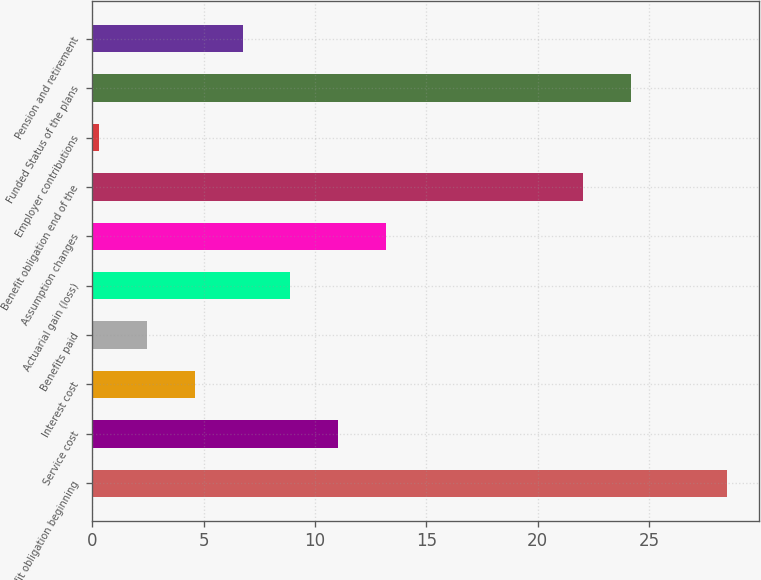Convert chart to OTSL. <chart><loc_0><loc_0><loc_500><loc_500><bar_chart><fcel>Benefit obligation beginning<fcel>Service cost<fcel>Interest cost<fcel>Benefits paid<fcel>Actuarial gain (loss)<fcel>Assumption changes<fcel>Benefit obligation end of the<fcel>Employer contributions<fcel>Funded Status of the plans<fcel>Pension and retirement<nl><fcel>28.5<fcel>11.05<fcel>4.6<fcel>2.45<fcel>8.9<fcel>13.2<fcel>22.05<fcel>0.3<fcel>24.2<fcel>6.75<nl></chart> 